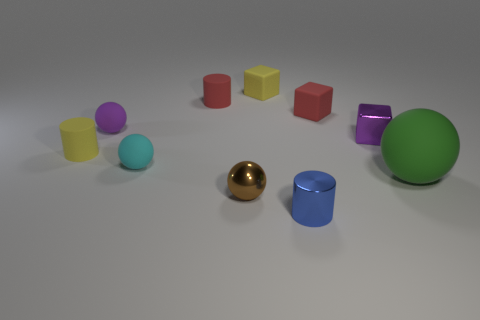Subtract all red matte cylinders. How many cylinders are left? 2 Subtract all purple spheres. How many spheres are left? 3 Subtract all spheres. How many objects are left? 6 Subtract 0 green cylinders. How many objects are left? 10 Subtract 3 balls. How many balls are left? 1 Subtract all cyan balls. Subtract all gray cubes. How many balls are left? 3 Subtract all red cylinders. How many cyan cubes are left? 0 Subtract all green rubber things. Subtract all small blocks. How many objects are left? 6 Add 5 tiny cylinders. How many tiny cylinders are left? 8 Add 4 small yellow rubber cubes. How many small yellow rubber cubes exist? 5 